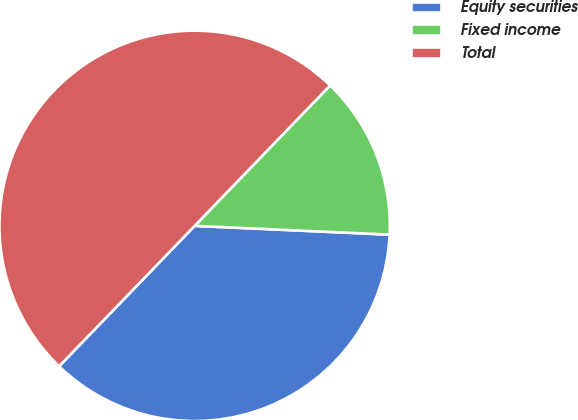<chart> <loc_0><loc_0><loc_500><loc_500><pie_chart><fcel>Equity securities<fcel>Fixed income<fcel>Total<nl><fcel>36.5%<fcel>13.5%<fcel>50.0%<nl></chart> 